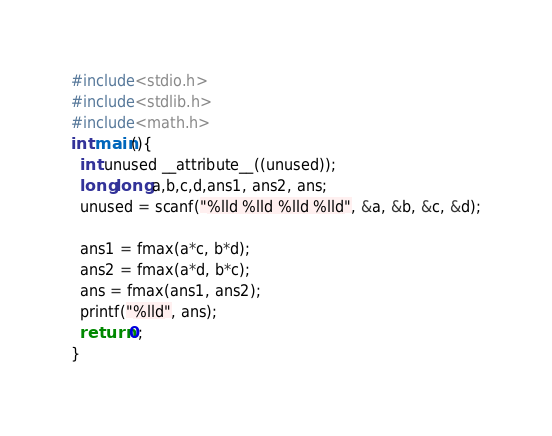<code> <loc_0><loc_0><loc_500><loc_500><_C_>#include<stdio.h>
#include<stdlib.h>
#include<math.h>
int main(){
  int unused __attribute__((unused));
  long long a,b,c,d,ans1, ans2, ans;
  unused = scanf("%lld %lld %lld %lld", &a, &b, &c, &d);

  ans1 = fmax(a*c, b*d);
  ans2 = fmax(a*d, b*c);
  ans = fmax(ans1, ans2);
  printf("%lld", ans);
  return 0;
}</code> 